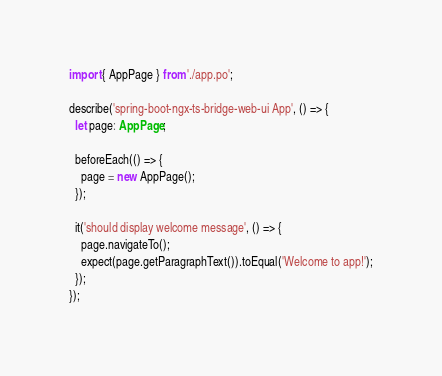Convert code to text. <code><loc_0><loc_0><loc_500><loc_500><_TypeScript_>import { AppPage } from './app.po';

describe('spring-boot-ngx-ts-bridge-web-ui App', () => {
  let page: AppPage;

  beforeEach(() => {
    page = new AppPage();
  });

  it('should display welcome message', () => {
    page.navigateTo();
    expect(page.getParagraphText()).toEqual('Welcome to app!');
  });
});
</code> 